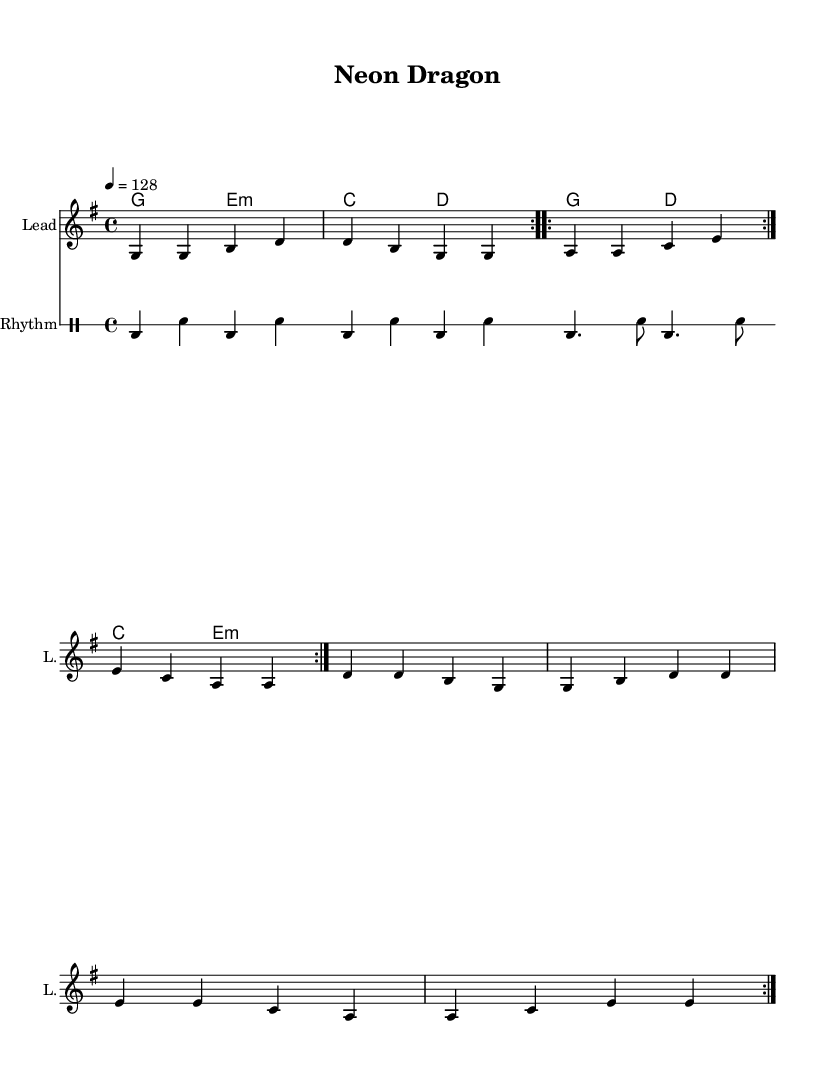What is the key signature of this music? The key signature is G major, which has one sharp (F#). This can be determined by looking at the key signature placed at the beginning of the sheet music.
Answer: G major What is the time signature of this music? The time signature is 4/4, indicated by the fraction seen at the beginning of the score. This means there are four beats in each measure and the quarter note gets one beat.
Answer: 4/4 What is the tempo marking of this piece? The tempo marking indicates a speed of 128 beats per minute. This is found just below the time signature, represented as "4 = 128".
Answer: 128 How many measures are in the verse section? The verse section contains 8 measures. This can be determined by counting the grouped sets of four beats in the melody and drums.
Answer: 8 What type of chords are predominantly used in this piece? The piece predominantly uses major and minor chords, specifically G major and E minor, as denoted by the chord symbols underneath the staff.
Answer: Major and minor What is the characteristic rhythmic pattern for the chorus? The chorus features a "bd4. sn8 bd4. sn8" rhythmic pattern indicating a bass drum and snare alternating throughout the section. This specific pattern can be identified in the drum rhythm section marked for the chorus.
Answer: Bass and snare pattern How does the melody vary in the repeated sections? The melody does not vary in the repeated sections; it is identical in both the first and second volta, which can be seen in the repeat signs marking the volta.
Answer: No variation 